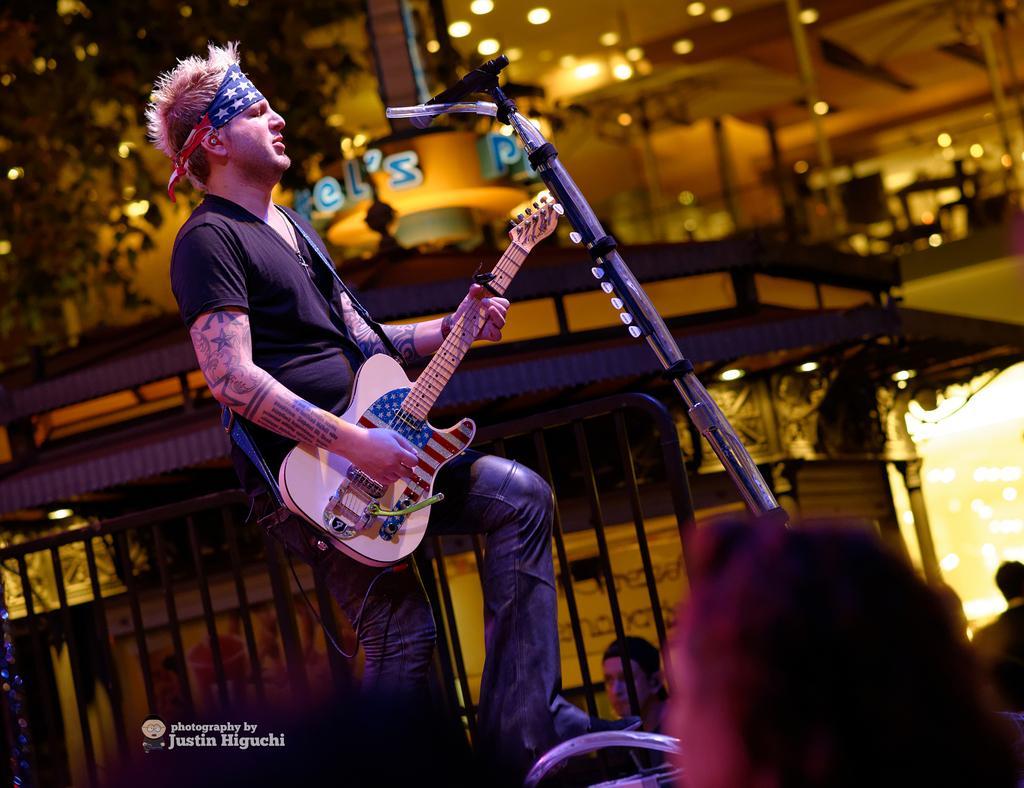Please provide a concise description of this image. This person is playing guitar in-front of mic. These are audience. Far there is a building and tree. 